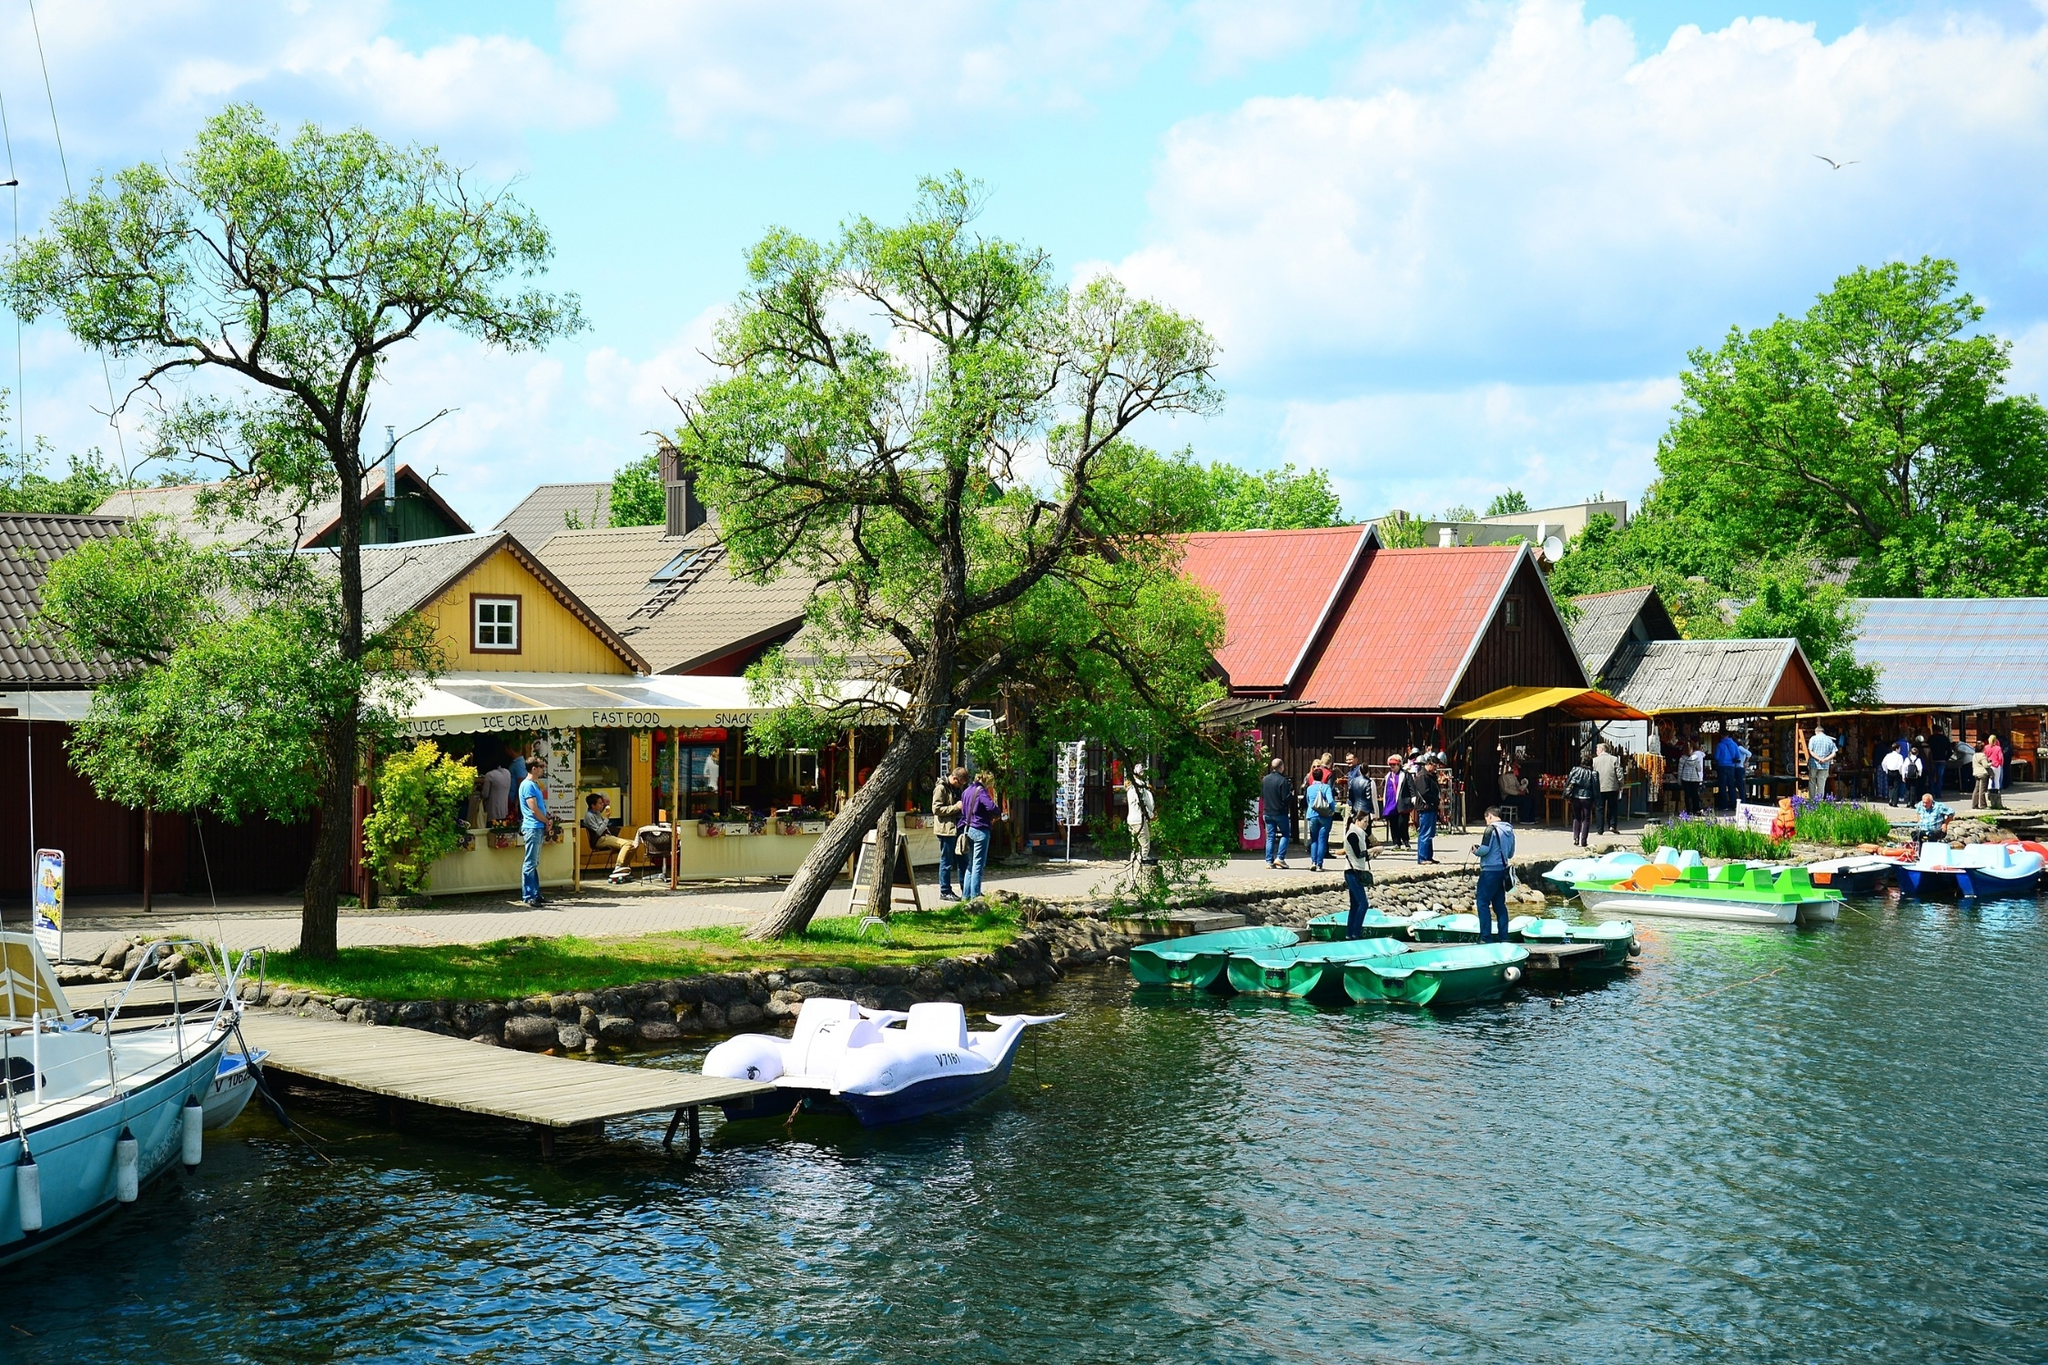What's happening in the scene? The image depicts a picturesque village scene by a serene lake. The village is surrounded by lush greenery, with charming wooden houses featuring red and yellow roofs. At the forefront, there's a dock extending into the lake with various paddle boats, suggesting recreational activities like boating. The atmosphere is lively with people walking around and a small crowd gathered near a lakeside kiosk that offers juice, ice cream, fast food, and snacks. The clear blue sky with scattered fluffy white clouds adds to the picturesque and tranquil ambiance of the village. 